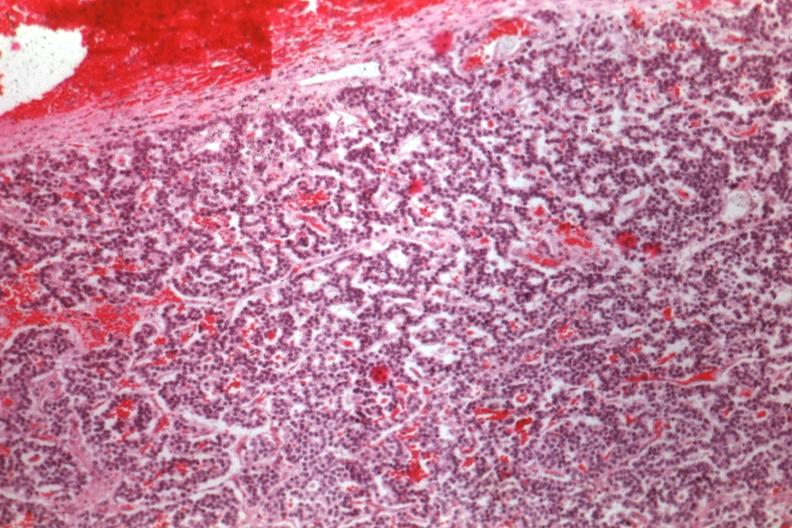s quite good liver present?
Answer the question using a single word or phrase. No 